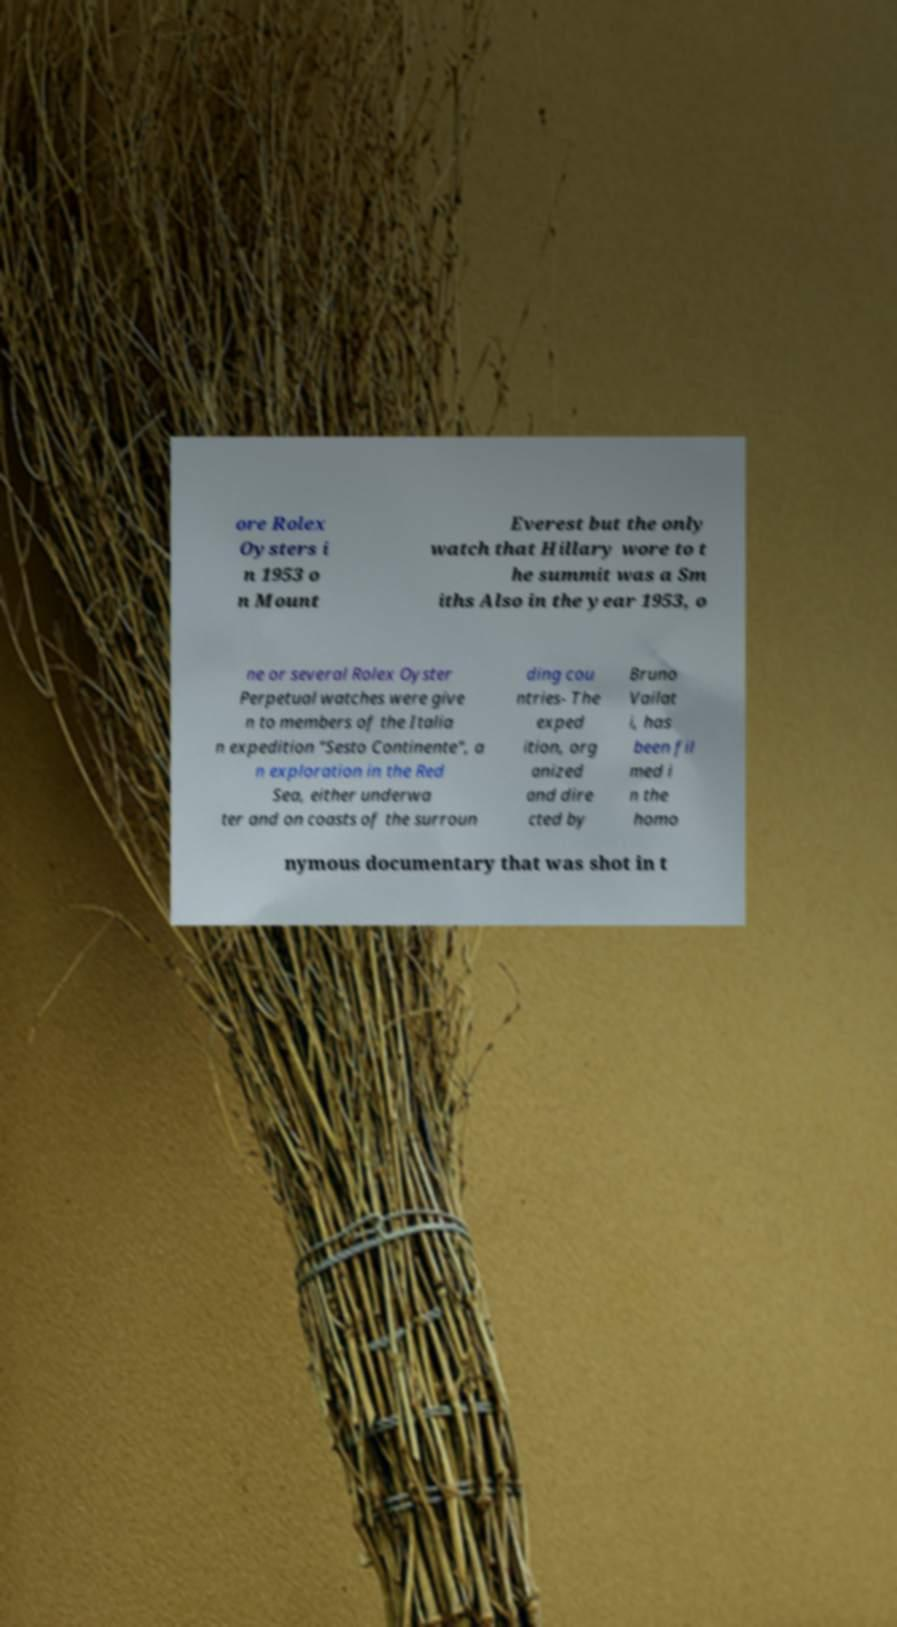For documentation purposes, I need the text within this image transcribed. Could you provide that? ore Rolex Oysters i n 1953 o n Mount Everest but the only watch that Hillary wore to t he summit was a Sm iths Also in the year 1953, o ne or several Rolex Oyster Perpetual watches were give n to members of the Italia n expedition "Sesto Continente", a n exploration in the Red Sea, either underwa ter and on coasts of the surroun ding cou ntries- The exped ition, org anized and dire cted by Bruno Vailat i, has been fil med i n the homo nymous documentary that was shot in t 